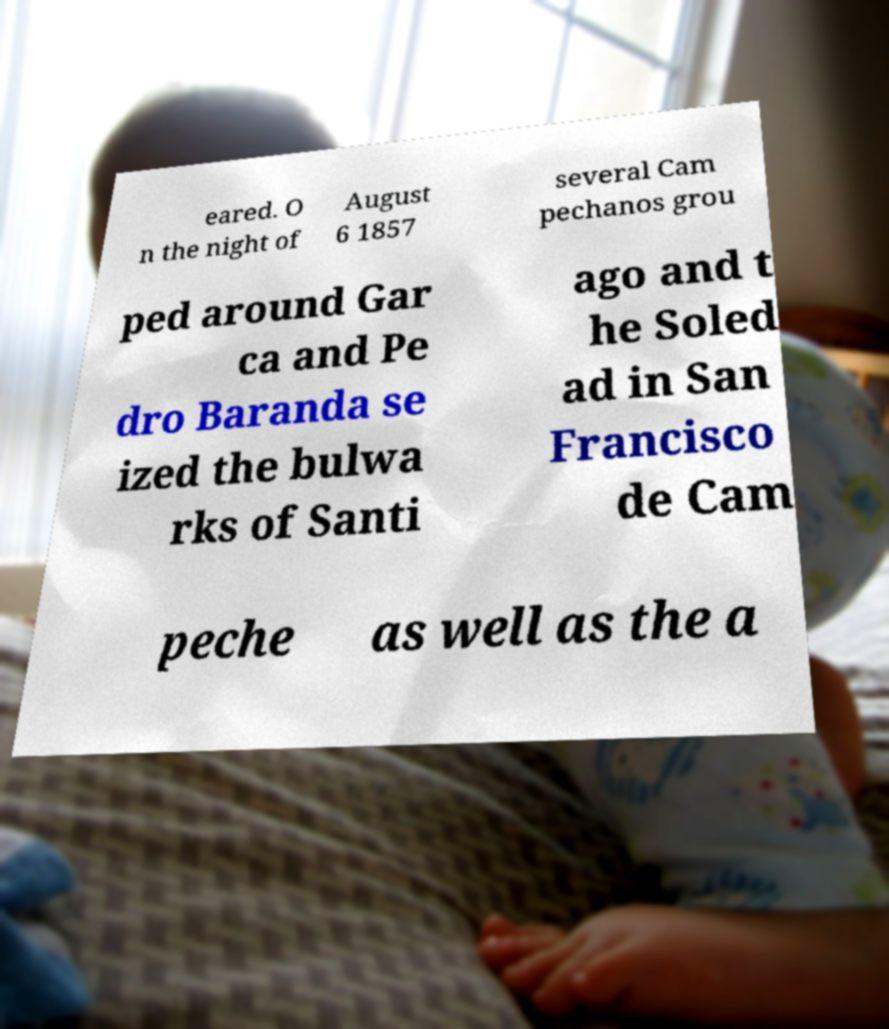Could you assist in decoding the text presented in this image and type it out clearly? eared. O n the night of August 6 1857 several Cam pechanos grou ped around Gar ca and Pe dro Baranda se ized the bulwa rks of Santi ago and t he Soled ad in San Francisco de Cam peche as well as the a 